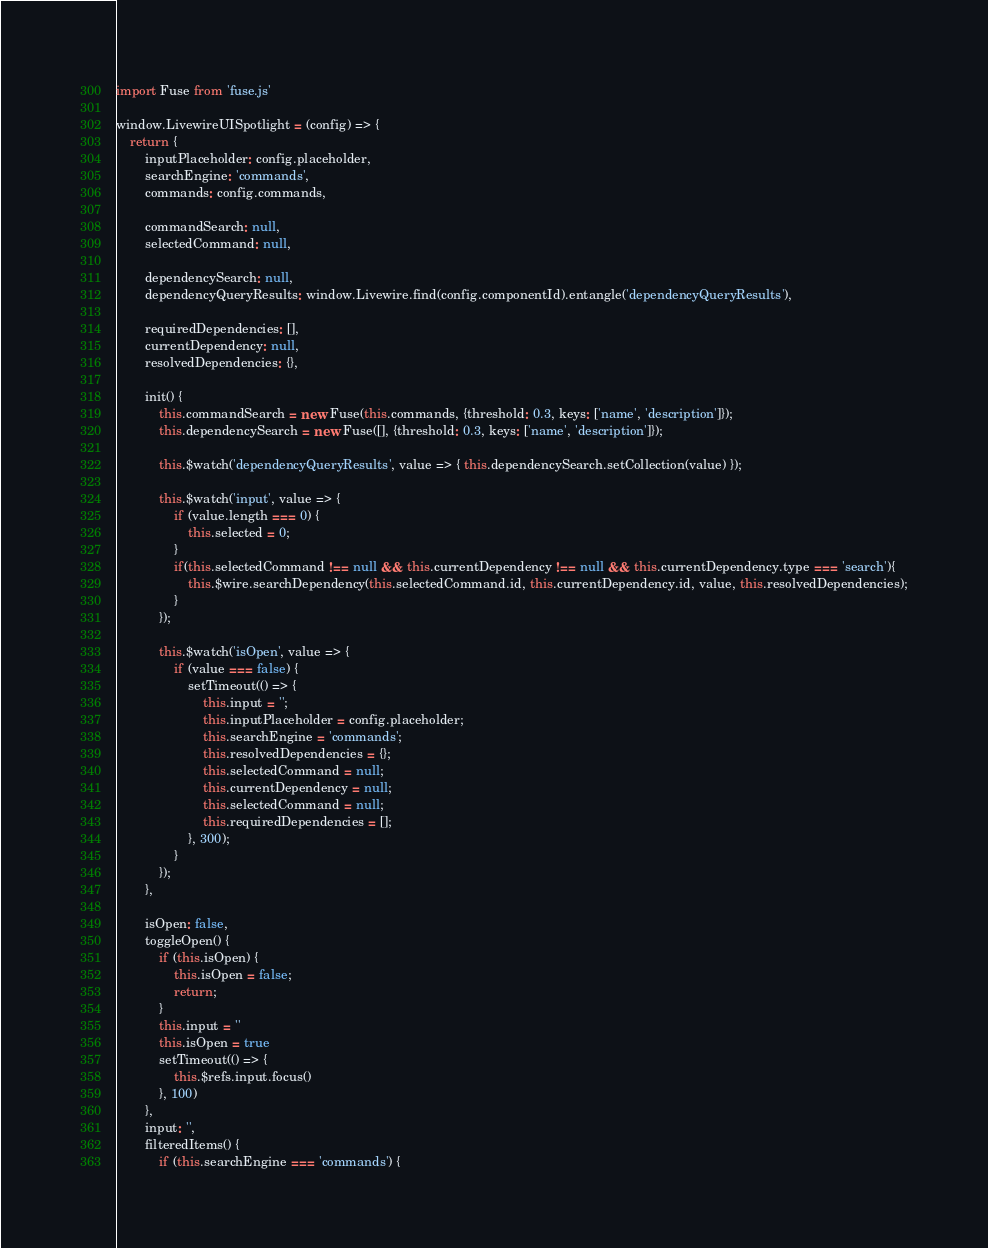<code> <loc_0><loc_0><loc_500><loc_500><_JavaScript_>import Fuse from 'fuse.js'

window.LivewireUISpotlight = (config) => {
    return {
        inputPlaceholder: config.placeholder,
        searchEngine: 'commands',
        commands: config.commands,

        commandSearch: null,
        selectedCommand: null,

        dependencySearch: null,
        dependencyQueryResults: window.Livewire.find(config.componentId).entangle('dependencyQueryResults'),

        requiredDependencies: [],
        currentDependency: null,
        resolvedDependencies: {},

        init() {
            this.commandSearch = new Fuse(this.commands, {threshold: 0.3, keys: ['name', 'description']});
            this.dependencySearch = new Fuse([], {threshold: 0.3, keys: ['name', 'description']});

            this.$watch('dependencyQueryResults', value => { this.dependencySearch.setCollection(value) });

            this.$watch('input', value => {
                if (value.length === 0) {
                    this.selected = 0;
                }
                if(this.selectedCommand !== null && this.currentDependency !== null && this.currentDependency.type === 'search'){
                    this.$wire.searchDependency(this.selectedCommand.id, this.currentDependency.id, value, this.resolvedDependencies);
                }
            });

            this.$watch('isOpen', value => {
                if (value === false) {
                    setTimeout(() => {
                        this.input = '';
                        this.inputPlaceholder = config.placeholder;
                        this.searchEngine = 'commands';
                        this.resolvedDependencies = {};
                        this.selectedCommand = null;
                        this.currentDependency = null;
                        this.selectedCommand = null;
                        this.requiredDependencies = [];
                    }, 300);
                }
            });
        },

        isOpen: false,
        toggleOpen() {
            if (this.isOpen) {
                this.isOpen = false;
                return;
            }
            this.input = ''
            this.isOpen = true
            setTimeout(() => {
                this.$refs.input.focus()
            }, 100)
        },
        input: '',
        filteredItems() {
            if (this.searchEngine === 'commands') {</code> 